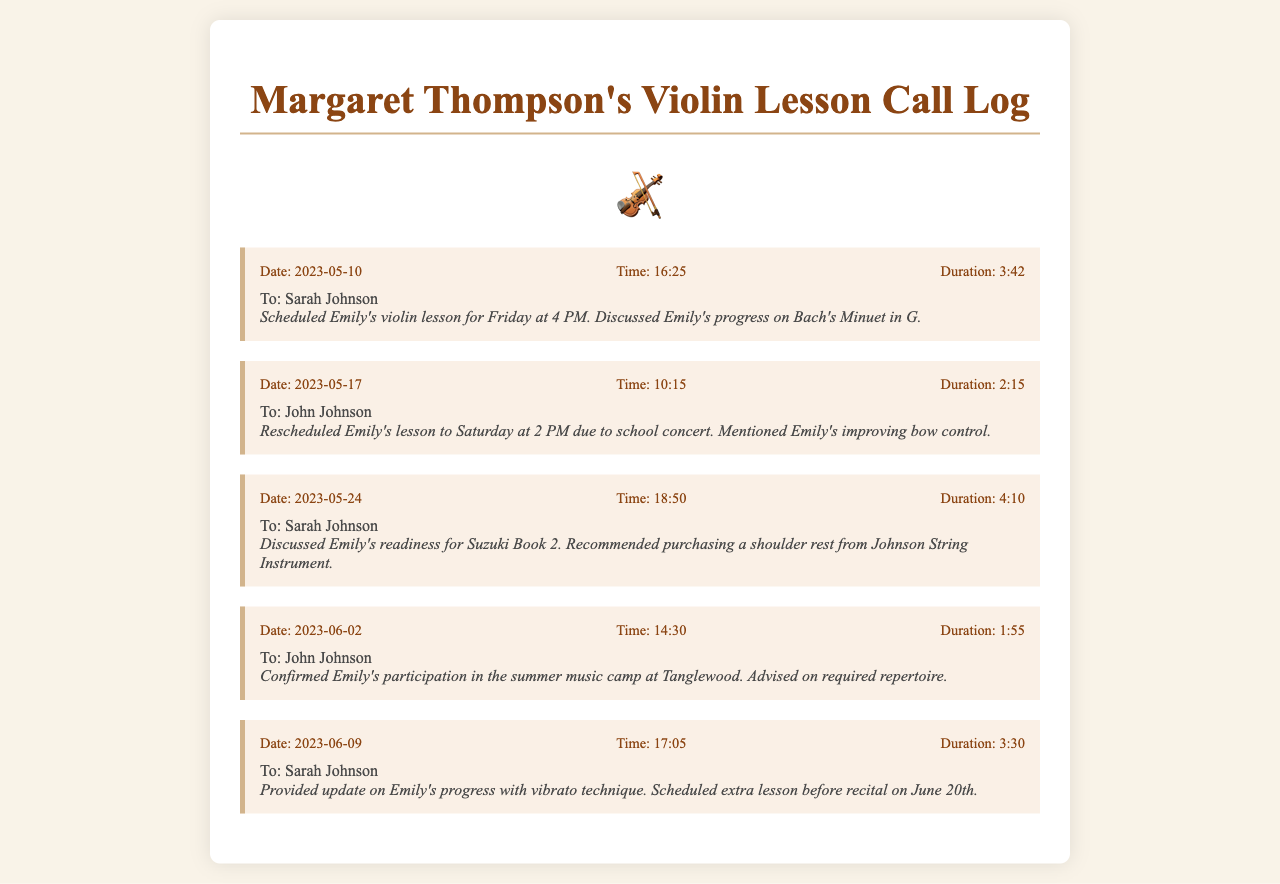What is the date of the first call? The first call was on May 10, 2023, as listed in the document.
Answer: May 10, 2023 Who is the first call to? The first call was made to Sarah Johnson, noted in the call log.
Answer: Sarah Johnson What time was the lesson scheduled on May 10? The lesson was scheduled for Friday at 4 PM, mentioned in the call summary.
Answer: 4 PM How long did the call on May 17 last? The call duration for the May 17 call is mentioned as 2 minutes and 15 seconds.
Answer: 2:15 What was discussed during the call on June 09? The call log mentions an update on Emily's progress with vibrato technique.
Answer: Vibrato technique How many calls were made to John Johnson? A total of two calls were made to John Johnson, as evidenced by the entries in the log.
Answer: 2 What recommendation was made on May 24? The recommendation made was to purchase a shoulder rest from Johnson String Instrument.
Answer: Shoulder rest What is the purpose of the calls recorded? The calls are for coordinating lesson schedules and providing progress updates about Emily.
Answer: Coordinating lessons and progress updates Which event was confirmed during the call on June 02? The call confirmed Emily's participation in the summer music camp at Tanglewood.
Answer: Summer music camp at Tanglewood 